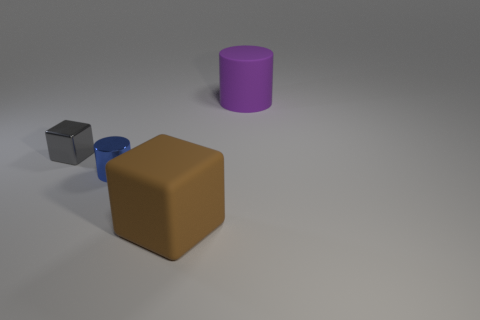Add 3 tiny green matte balls. How many objects exist? 7 Subtract all metal cylinders. Subtract all blue things. How many objects are left? 2 Add 4 tiny gray metallic blocks. How many tiny gray metallic blocks are left? 5 Add 4 green objects. How many green objects exist? 4 Subtract 1 blue cylinders. How many objects are left? 3 